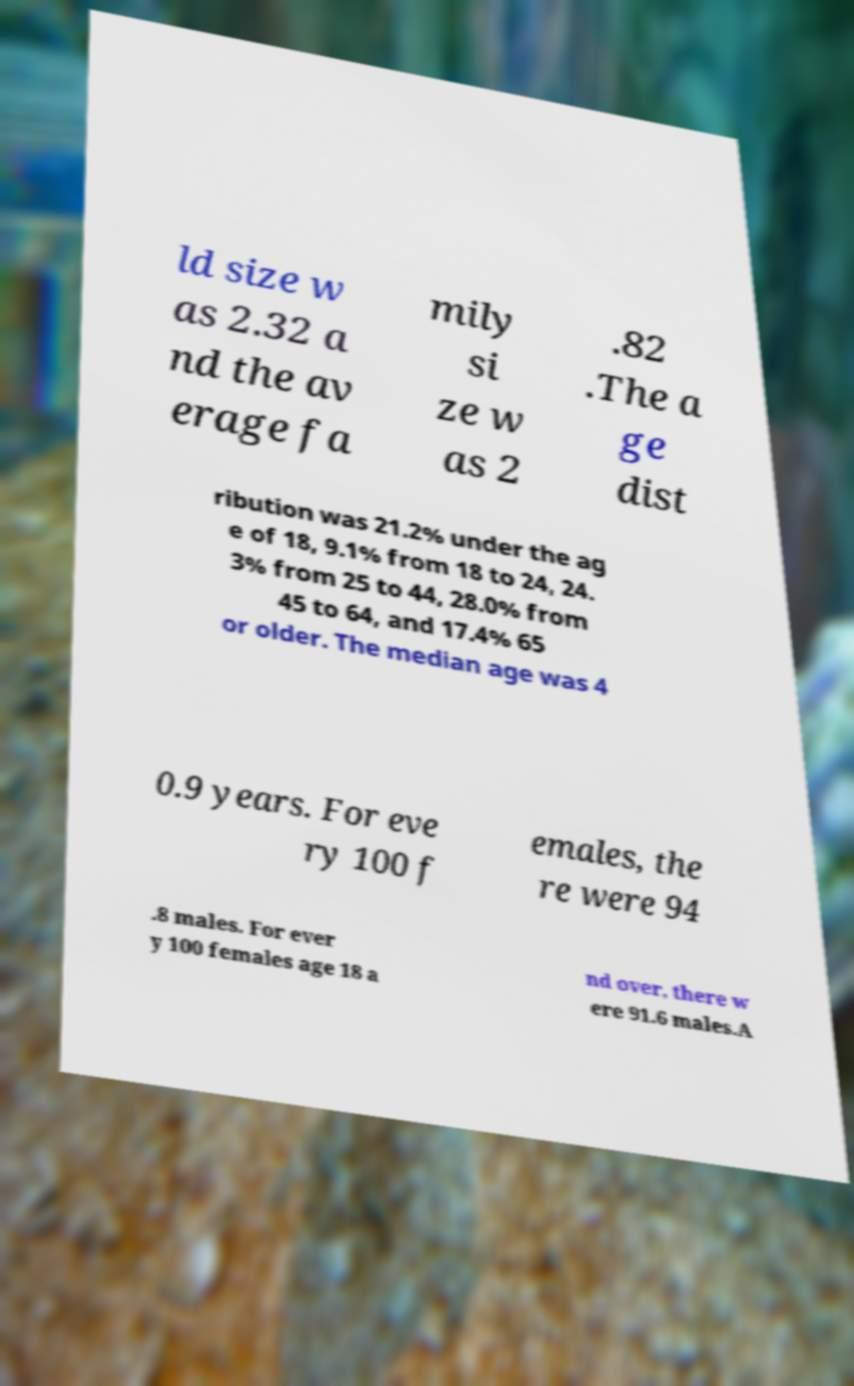Could you extract and type out the text from this image? ld size w as 2.32 a nd the av erage fa mily si ze w as 2 .82 .The a ge dist ribution was 21.2% under the ag e of 18, 9.1% from 18 to 24, 24. 3% from 25 to 44, 28.0% from 45 to 64, and 17.4% 65 or older. The median age was 4 0.9 years. For eve ry 100 f emales, the re were 94 .8 males. For ever y 100 females age 18 a nd over, there w ere 91.6 males.A 